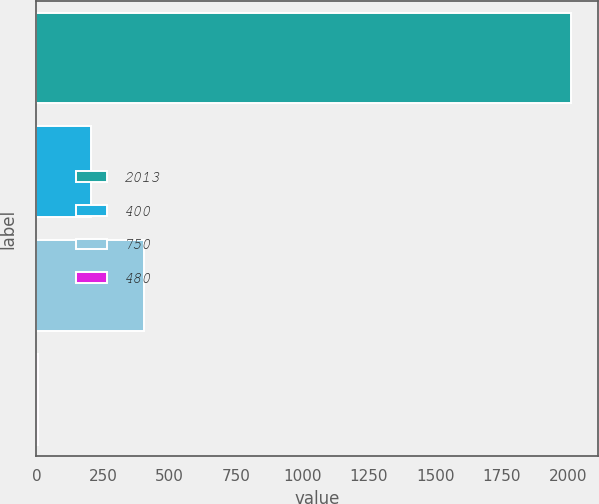Convert chart. <chart><loc_0><loc_0><loc_500><loc_500><bar_chart><fcel>2013<fcel>400<fcel>750<fcel>480<nl><fcel>2011<fcel>205.6<fcel>406.2<fcel>5<nl></chart> 